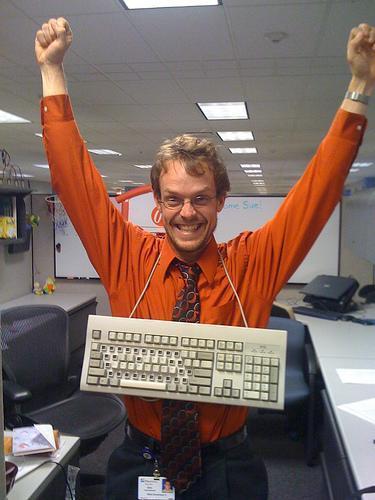How many chairs are there?
Give a very brief answer. 2. 